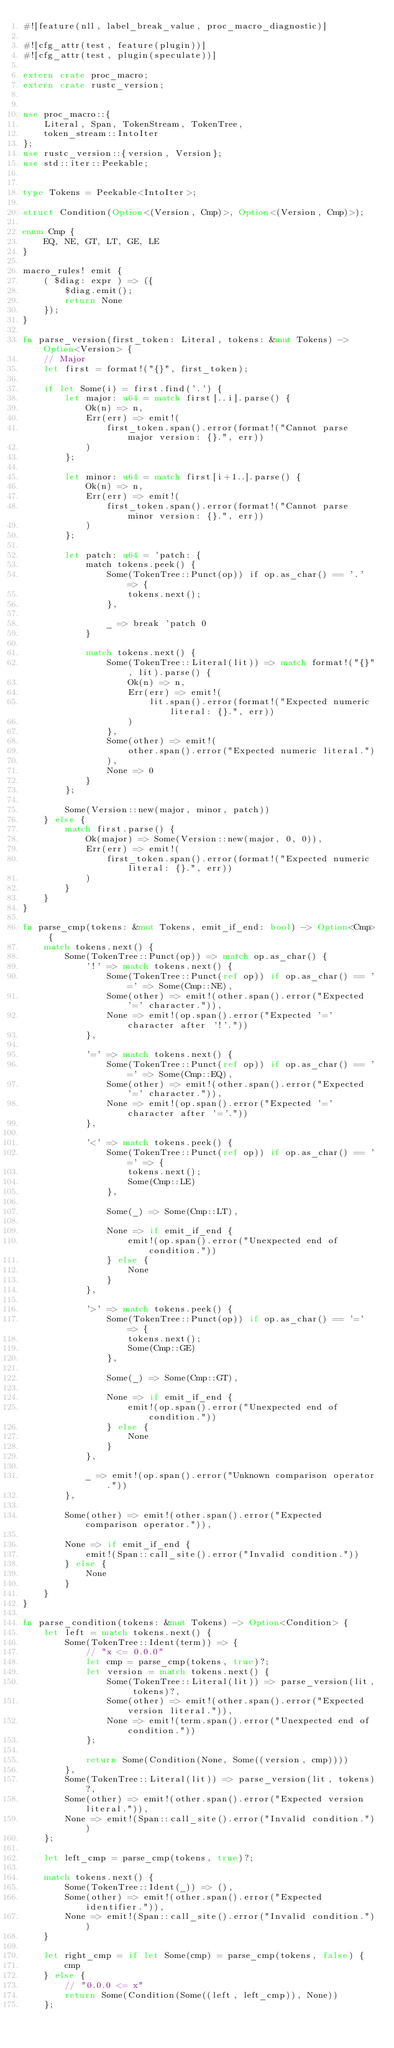<code> <loc_0><loc_0><loc_500><loc_500><_Rust_>#![feature(nll, label_break_value, proc_macro_diagnostic)]

#![cfg_attr(test, feature(plugin))]
#![cfg_attr(test, plugin(speculate))]

extern crate proc_macro;
extern crate rustc_version;


use proc_macro::{
    Literal, Span, TokenStream, TokenTree,
    token_stream::IntoIter
};
use rustc_version::{version, Version};
use std::iter::Peekable;


type Tokens = Peekable<IntoIter>;

struct Condition(Option<(Version, Cmp)>, Option<(Version, Cmp)>);

enum Cmp {
    EQ, NE, GT, LT, GE, LE
}

macro_rules! emit {
    ( $diag: expr ) => ({
        $diag.emit();
        return None
    });
}

fn parse_version(first_token: Literal, tokens: &mut Tokens) -> Option<Version> {
    // Major
    let first = format!("{}", first_token);

    if let Some(i) = first.find('.') {
        let major: u64 = match first[..i].parse() {
            Ok(n) => n,
            Err(err) => emit!(
                first_token.span().error(format!("Cannot parse major version: {}.", err))
            )
        };

        let minor: u64 = match first[i+1..].parse() {
            Ok(n) => n,
            Err(err) => emit!(
                first_token.span().error(format!("Cannot parse minor version: {}.", err))
            )
        };

        let patch: u64 = 'patch: {
            match tokens.peek() {
                Some(TokenTree::Punct(op)) if op.as_char() == '.' => {
                    tokens.next();
                },

                _ => break 'patch 0
            }
            
            match tokens.next() {
                Some(TokenTree::Literal(lit)) => match format!("{}", lit).parse() {
                    Ok(n) => n,
                    Err(err) => emit!(
                        lit.span().error(format!("Expected numeric literal: {}.", err))
                    )
                },
                Some(other) => emit!(
                    other.span().error("Expected numeric literal.")
                ),
                None => 0
            }
        };

        Some(Version::new(major, minor, patch))
    } else {
        match first.parse() {
            Ok(major) => Some(Version::new(major, 0, 0)),
            Err(err) => emit!(
                first_token.span().error(format!("Expected numeric literal: {}.", err))
            )
        }
    }
}

fn parse_cmp(tokens: &mut Tokens, emit_if_end: bool) -> Option<Cmp> {
    match tokens.next() {
        Some(TokenTree::Punct(op)) => match op.as_char() {
            '!' => match tokens.next() {
                Some(TokenTree::Punct(ref op)) if op.as_char() == '=' => Some(Cmp::NE),
                Some(other) => emit!(other.span().error("Expected '=' character.")),
                None => emit!(op.span().error("Expected '=' character after '!'."))
            },

            '=' => match tokens.next() {
                Some(TokenTree::Punct(ref op)) if op.as_char() == '=' => Some(Cmp::EQ),
                Some(other) => emit!(other.span().error("Expected '=' character.")),
                None => emit!(op.span().error("Expected '=' character after '='."))
            },

            '<' => match tokens.peek() {
                Some(TokenTree::Punct(ref op)) if op.as_char() == '=' => {
                    tokens.next();
                    Some(Cmp::LE)
                },

                Some(_) => Some(Cmp::LT),
                
                None => if emit_if_end {
                    emit!(op.span().error("Unexpected end of condition."))
                } else {
                    None
                }
            },

            '>' => match tokens.peek() {
                Some(TokenTree::Punct(op)) if op.as_char() == '=' => {
                    tokens.next();
                    Some(Cmp::GE)
                },
                
                Some(_) => Some(Cmp::GT),
                
                None => if emit_if_end {
                    emit!(op.span().error("Unexpected end of condition."))
                } else {
                    None
                }
            },

            _ => emit!(op.span().error("Unknown comparison operator."))
        },
        
        Some(other) => emit!(other.span().error("Expected comparison operator.")),
        
        None => if emit_if_end {
            emit!(Span::call_site().error("Invalid condition."))
        } else {
            None
        }
    }
}

fn parse_condition(tokens: &mut Tokens) -> Option<Condition> {
    let left = match tokens.next() {
        Some(TokenTree::Ident(term)) => {
            // "x <= 0.0.0"
            let cmp = parse_cmp(tokens, true)?;
            let version = match tokens.next() {
                Some(TokenTree::Literal(lit)) => parse_version(lit, tokens)?,
                Some(other) => emit!(other.span().error("Expected version literal.")),
                None => emit!(term.span().error("Unexpected end of condition."))
            };

            return Some(Condition(None, Some((version, cmp))))
        },
        Some(TokenTree::Literal(lit)) => parse_version(lit, tokens)?,
        Some(other) => emit!(other.span().error("Expected version literal.")),
        None => emit!(Span::call_site().error("Invalid condition."))
    };

    let left_cmp = parse_cmp(tokens, true)?;

    match tokens.next() {
        Some(TokenTree::Ident(_)) => (),
        Some(other) => emit!(other.span().error("Expected identifier.")),
        None => emit!(Span::call_site().error("Invalid condition."))
    }

    let right_cmp = if let Some(cmp) = parse_cmp(tokens, false) {
        cmp
    } else {
        // "0.0.0 <= x"
        return Some(Condition(Some((left, left_cmp)), None))
    };
</code> 